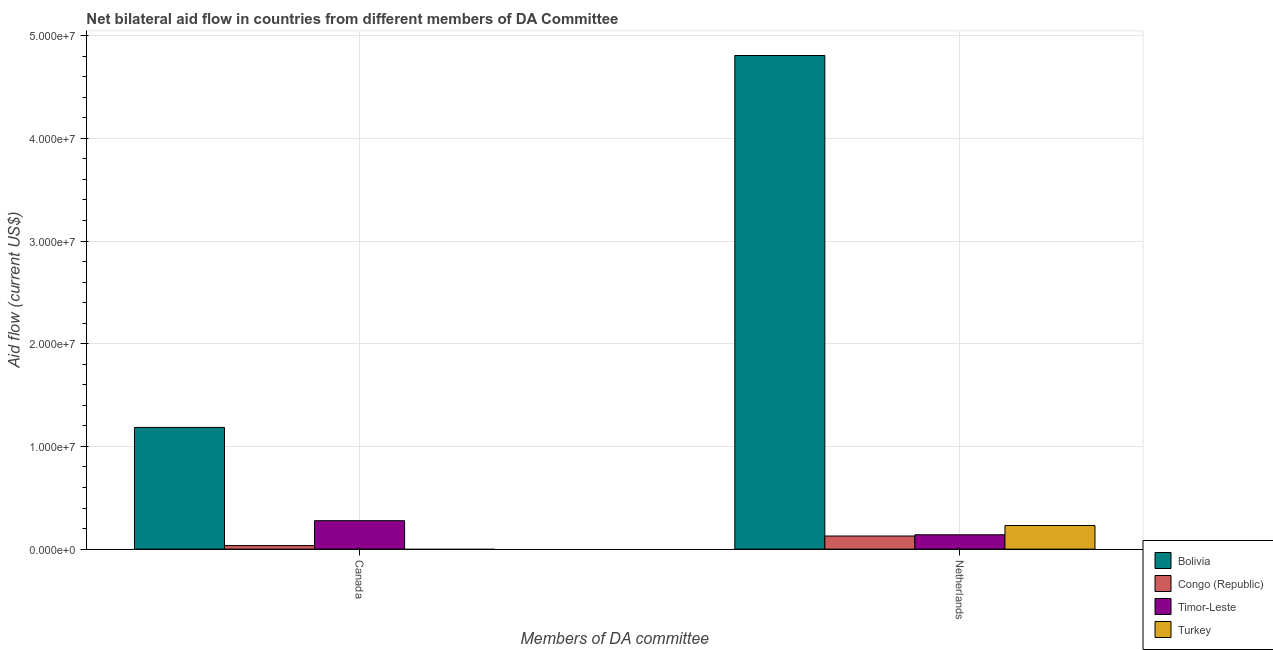How many groups of bars are there?
Your response must be concise. 2. How many bars are there on the 2nd tick from the left?
Provide a succinct answer. 4. How many bars are there on the 2nd tick from the right?
Offer a very short reply. 3. What is the amount of aid given by canada in Congo (Republic)?
Provide a short and direct response. 3.50e+05. Across all countries, what is the maximum amount of aid given by canada?
Offer a very short reply. 1.18e+07. Across all countries, what is the minimum amount of aid given by netherlands?
Your answer should be compact. 1.28e+06. What is the total amount of aid given by netherlands in the graph?
Your answer should be very brief. 5.30e+07. What is the difference between the amount of aid given by canada in Bolivia and that in Timor-Leste?
Provide a succinct answer. 9.08e+06. What is the difference between the amount of aid given by netherlands in Turkey and the amount of aid given by canada in Bolivia?
Your answer should be very brief. -9.55e+06. What is the average amount of aid given by canada per country?
Offer a terse response. 3.74e+06. What is the difference between the amount of aid given by netherlands and amount of aid given by canada in Bolivia?
Your answer should be compact. 3.62e+07. What is the ratio of the amount of aid given by netherlands in Congo (Republic) to that in Bolivia?
Your answer should be compact. 0.03. Is the amount of aid given by netherlands in Bolivia less than that in Congo (Republic)?
Ensure brevity in your answer.  No. In how many countries, is the amount of aid given by canada greater than the average amount of aid given by canada taken over all countries?
Provide a succinct answer. 1. How many countries are there in the graph?
Your answer should be compact. 4. What is the difference between two consecutive major ticks on the Y-axis?
Keep it short and to the point. 1.00e+07. Does the graph contain any zero values?
Your answer should be compact. Yes. Does the graph contain grids?
Your response must be concise. Yes. How many legend labels are there?
Keep it short and to the point. 4. How are the legend labels stacked?
Provide a succinct answer. Vertical. What is the title of the graph?
Give a very brief answer. Net bilateral aid flow in countries from different members of DA Committee. Does "Dominica" appear as one of the legend labels in the graph?
Provide a short and direct response. No. What is the label or title of the X-axis?
Your response must be concise. Members of DA committee. What is the Aid flow (current US$) of Bolivia in Canada?
Your answer should be very brief. 1.18e+07. What is the Aid flow (current US$) of Congo (Republic) in Canada?
Make the answer very short. 3.50e+05. What is the Aid flow (current US$) of Timor-Leste in Canada?
Provide a succinct answer. 2.77e+06. What is the Aid flow (current US$) in Bolivia in Netherlands?
Provide a short and direct response. 4.81e+07. What is the Aid flow (current US$) of Congo (Republic) in Netherlands?
Your answer should be compact. 1.28e+06. What is the Aid flow (current US$) of Timor-Leste in Netherlands?
Offer a very short reply. 1.40e+06. What is the Aid flow (current US$) in Turkey in Netherlands?
Provide a succinct answer. 2.30e+06. Across all Members of DA committee, what is the maximum Aid flow (current US$) of Bolivia?
Provide a short and direct response. 4.81e+07. Across all Members of DA committee, what is the maximum Aid flow (current US$) of Congo (Republic)?
Your answer should be compact. 1.28e+06. Across all Members of DA committee, what is the maximum Aid flow (current US$) of Timor-Leste?
Provide a short and direct response. 2.77e+06. Across all Members of DA committee, what is the maximum Aid flow (current US$) of Turkey?
Your response must be concise. 2.30e+06. Across all Members of DA committee, what is the minimum Aid flow (current US$) of Bolivia?
Keep it short and to the point. 1.18e+07. Across all Members of DA committee, what is the minimum Aid flow (current US$) of Timor-Leste?
Give a very brief answer. 1.40e+06. Across all Members of DA committee, what is the minimum Aid flow (current US$) of Turkey?
Offer a terse response. 0. What is the total Aid flow (current US$) in Bolivia in the graph?
Keep it short and to the point. 5.99e+07. What is the total Aid flow (current US$) of Congo (Republic) in the graph?
Your response must be concise. 1.63e+06. What is the total Aid flow (current US$) of Timor-Leste in the graph?
Provide a succinct answer. 4.17e+06. What is the total Aid flow (current US$) in Turkey in the graph?
Keep it short and to the point. 2.30e+06. What is the difference between the Aid flow (current US$) in Bolivia in Canada and that in Netherlands?
Make the answer very short. -3.62e+07. What is the difference between the Aid flow (current US$) in Congo (Republic) in Canada and that in Netherlands?
Provide a succinct answer. -9.30e+05. What is the difference between the Aid flow (current US$) in Timor-Leste in Canada and that in Netherlands?
Offer a very short reply. 1.37e+06. What is the difference between the Aid flow (current US$) in Bolivia in Canada and the Aid flow (current US$) in Congo (Republic) in Netherlands?
Give a very brief answer. 1.06e+07. What is the difference between the Aid flow (current US$) of Bolivia in Canada and the Aid flow (current US$) of Timor-Leste in Netherlands?
Your response must be concise. 1.04e+07. What is the difference between the Aid flow (current US$) of Bolivia in Canada and the Aid flow (current US$) of Turkey in Netherlands?
Offer a terse response. 9.55e+06. What is the difference between the Aid flow (current US$) in Congo (Republic) in Canada and the Aid flow (current US$) in Timor-Leste in Netherlands?
Keep it short and to the point. -1.05e+06. What is the difference between the Aid flow (current US$) in Congo (Republic) in Canada and the Aid flow (current US$) in Turkey in Netherlands?
Offer a very short reply. -1.95e+06. What is the average Aid flow (current US$) of Bolivia per Members of DA committee?
Offer a terse response. 3.00e+07. What is the average Aid flow (current US$) in Congo (Republic) per Members of DA committee?
Give a very brief answer. 8.15e+05. What is the average Aid flow (current US$) of Timor-Leste per Members of DA committee?
Your answer should be compact. 2.08e+06. What is the average Aid flow (current US$) in Turkey per Members of DA committee?
Your response must be concise. 1.15e+06. What is the difference between the Aid flow (current US$) of Bolivia and Aid flow (current US$) of Congo (Republic) in Canada?
Your response must be concise. 1.15e+07. What is the difference between the Aid flow (current US$) of Bolivia and Aid flow (current US$) of Timor-Leste in Canada?
Offer a very short reply. 9.08e+06. What is the difference between the Aid flow (current US$) in Congo (Republic) and Aid flow (current US$) in Timor-Leste in Canada?
Make the answer very short. -2.42e+06. What is the difference between the Aid flow (current US$) of Bolivia and Aid flow (current US$) of Congo (Republic) in Netherlands?
Offer a very short reply. 4.68e+07. What is the difference between the Aid flow (current US$) in Bolivia and Aid flow (current US$) in Timor-Leste in Netherlands?
Make the answer very short. 4.67e+07. What is the difference between the Aid flow (current US$) of Bolivia and Aid flow (current US$) of Turkey in Netherlands?
Your answer should be very brief. 4.58e+07. What is the difference between the Aid flow (current US$) of Congo (Republic) and Aid flow (current US$) of Turkey in Netherlands?
Ensure brevity in your answer.  -1.02e+06. What is the difference between the Aid flow (current US$) of Timor-Leste and Aid flow (current US$) of Turkey in Netherlands?
Your response must be concise. -9.00e+05. What is the ratio of the Aid flow (current US$) of Bolivia in Canada to that in Netherlands?
Give a very brief answer. 0.25. What is the ratio of the Aid flow (current US$) of Congo (Republic) in Canada to that in Netherlands?
Offer a terse response. 0.27. What is the ratio of the Aid flow (current US$) in Timor-Leste in Canada to that in Netherlands?
Make the answer very short. 1.98. What is the difference between the highest and the second highest Aid flow (current US$) of Bolivia?
Your answer should be compact. 3.62e+07. What is the difference between the highest and the second highest Aid flow (current US$) of Congo (Republic)?
Offer a terse response. 9.30e+05. What is the difference between the highest and the second highest Aid flow (current US$) in Timor-Leste?
Provide a short and direct response. 1.37e+06. What is the difference between the highest and the lowest Aid flow (current US$) of Bolivia?
Keep it short and to the point. 3.62e+07. What is the difference between the highest and the lowest Aid flow (current US$) in Congo (Republic)?
Give a very brief answer. 9.30e+05. What is the difference between the highest and the lowest Aid flow (current US$) of Timor-Leste?
Provide a succinct answer. 1.37e+06. What is the difference between the highest and the lowest Aid flow (current US$) in Turkey?
Provide a succinct answer. 2.30e+06. 